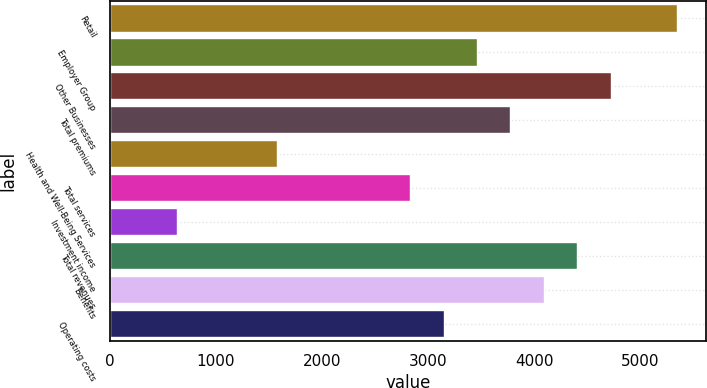Convert chart to OTSL. <chart><loc_0><loc_0><loc_500><loc_500><bar_chart><fcel>Retail<fcel>Employer Group<fcel>Other Businesses<fcel>Total premiums<fcel>Health and Well-Being Services<fcel>Total services<fcel>Investment income<fcel>Total revenues<fcel>Benefits<fcel>Operating costs<nl><fcel>5350.89<fcel>3462.69<fcel>4721.49<fcel>3777.39<fcel>1574.49<fcel>2833.29<fcel>630.39<fcel>4406.79<fcel>4092.09<fcel>3147.99<nl></chart> 